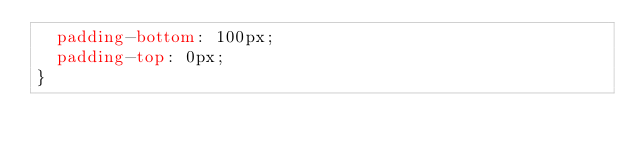<code> <loc_0><loc_0><loc_500><loc_500><_CSS_>  padding-bottom: 100px;
  padding-top: 0px;
}</code> 